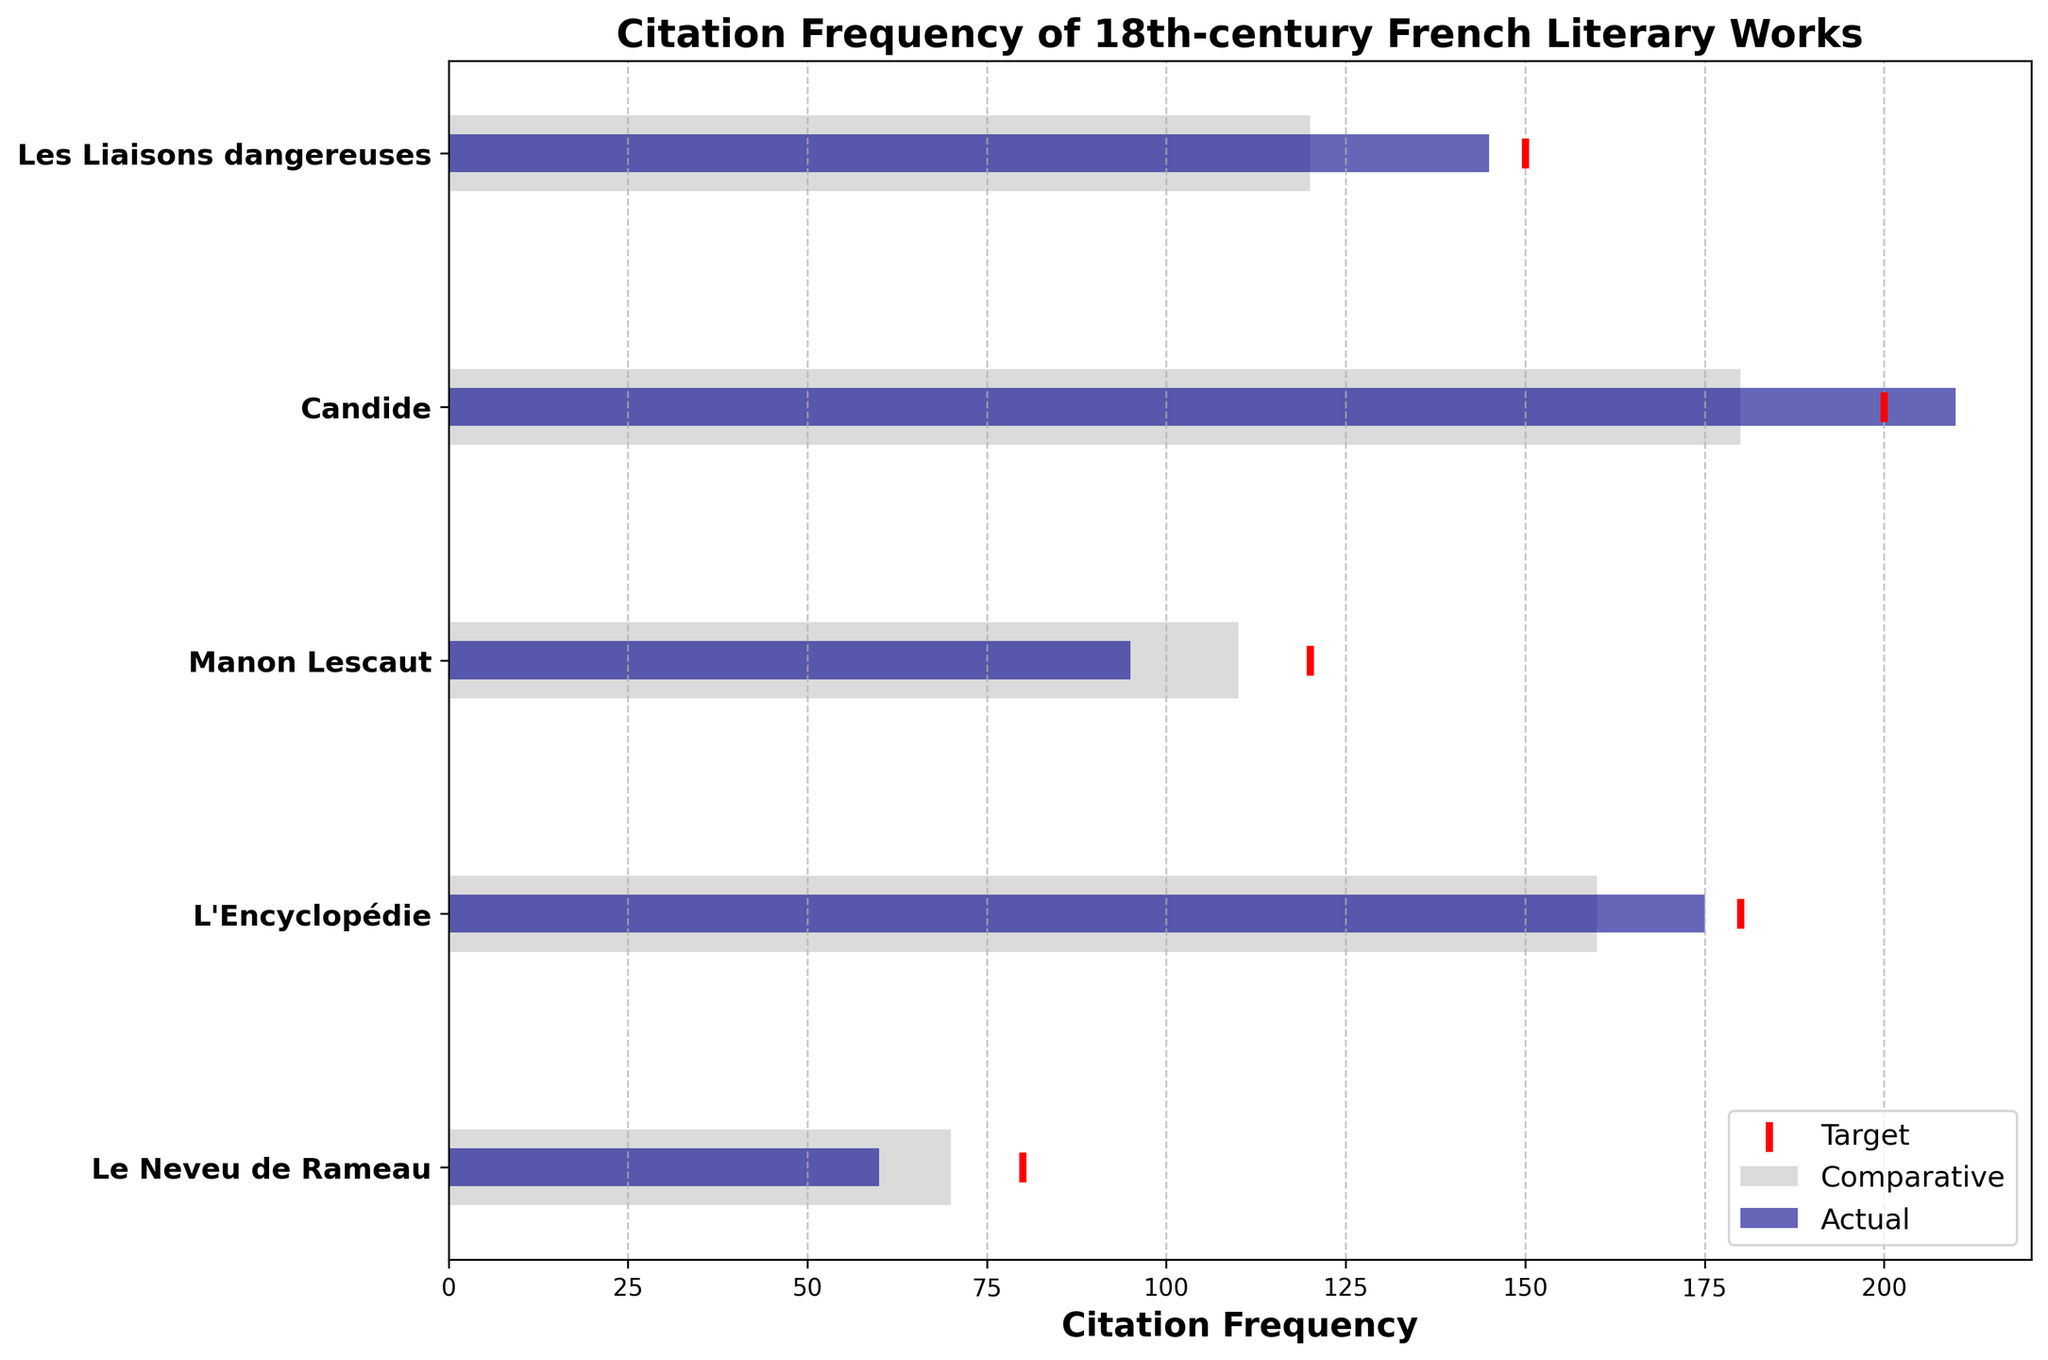What is the title of the chart? The title of the chart is located at the very top and typically summarises the main subject of the figure, making it easy to identify the chart's content.
Answer: Citation Frequency of 18th-century French Literary Works What color represents the actual citation frequency? By examining the legend, the "Actual" label is associated with the colored bar, which in this case is dark blue.
Answer: Dark blue What axis shows the citation frequency values? The x-axis of the chart displays numbered values representing citation frequencies, as indicated by the presence of numerical labels.
Answer: The x-axis Which work has the highest actual citation frequency? By looking at the dark blue bars' lengths, "Candide" has the longest dark blue bar, indicating it has the highest citation frequency.
Answer: Candide How many works have their actual citation frequency below their target frequency? Compare the length of the dark blue bars (actual) with the position of the red markers (target). "Les Liaisons dangereuses", "L'Encyclopédie", and "Le Neveu de Rameau" all have their actual citation frequency below their target frequency.
Answer: Three works What is the difference between the target and actual citation frequency for "L'Encyclopédie"? Subtract the actual citation frequency (175) from the target citation frequency (180) for "L'Encyclopédie". The difference is 180 - 175 = 5.
Answer: 5 Which work has been cited more than its respective target frequency? Compare each actual citation frequency with its target frequency. "Candide" is the only work where the actual citation frequency (210) exceeds the target frequency (200).
Answer: Candide 